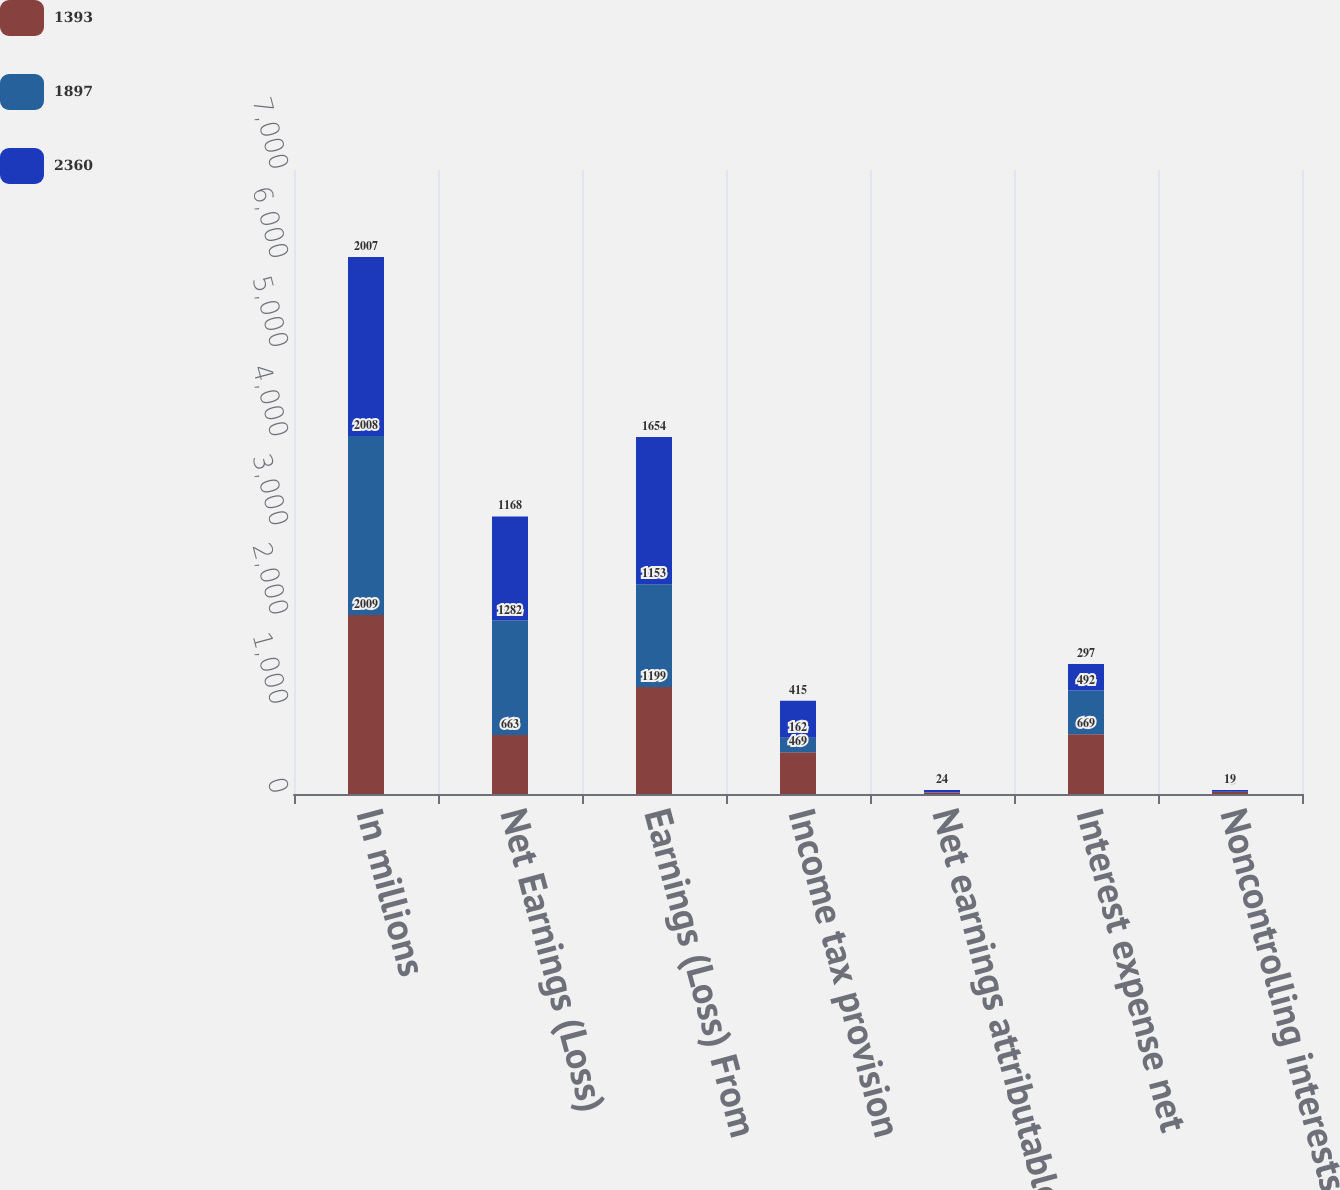Convert chart. <chart><loc_0><loc_0><loc_500><loc_500><stacked_bar_chart><ecel><fcel>In millions<fcel>Net Earnings (Loss)<fcel>Earnings (Loss) From<fcel>Income tax provision<fcel>Net earnings attributable to<fcel>Interest expense net<fcel>Noncontrolling interests /<nl><fcel>1393<fcel>2009<fcel>663<fcel>1199<fcel>469<fcel>18<fcel>669<fcel>23<nl><fcel>1897<fcel>2008<fcel>1282<fcel>1153<fcel>162<fcel>3<fcel>492<fcel>2<nl><fcel>2360<fcel>2007<fcel>1168<fcel>1654<fcel>415<fcel>24<fcel>297<fcel>19<nl></chart> 